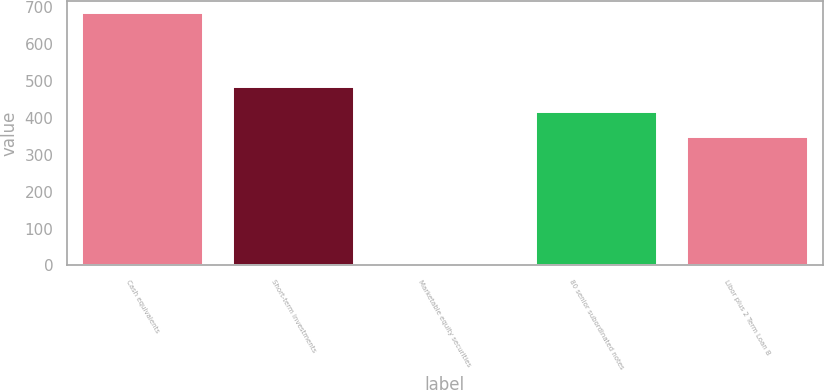Convert chart. <chart><loc_0><loc_0><loc_500><loc_500><bar_chart><fcel>Cash equivalents<fcel>Short-term investments<fcel>Marketable equity securities<fcel>80 senior subordinated notes<fcel>Libor plus 2 Term Loan B<nl><fcel>684<fcel>483.8<fcel>5<fcel>415.9<fcel>348<nl></chart> 